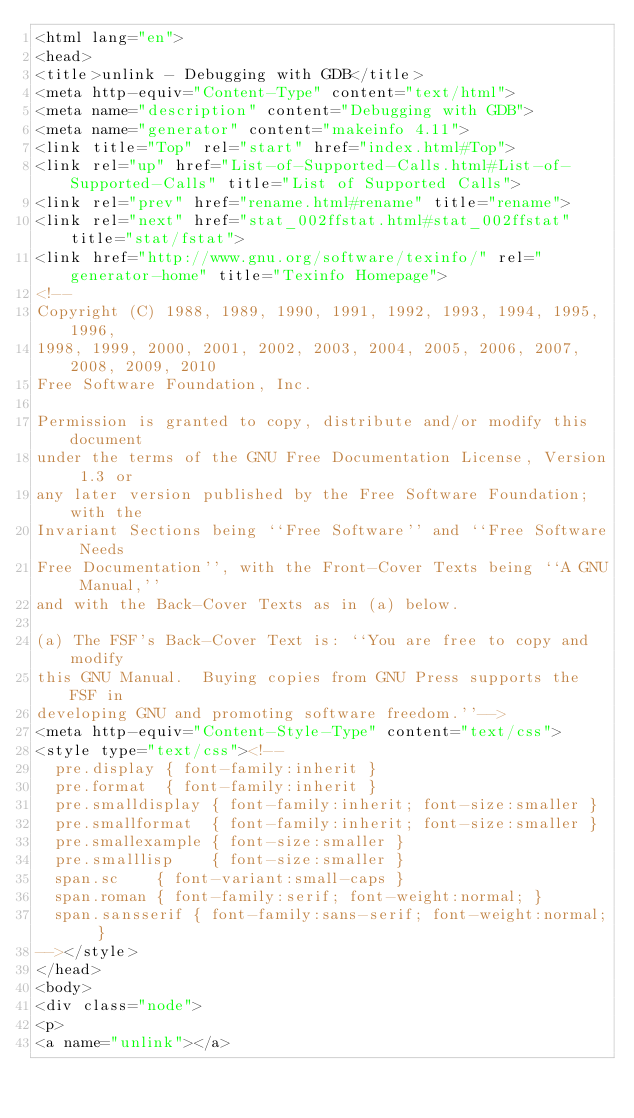<code> <loc_0><loc_0><loc_500><loc_500><_HTML_><html lang="en">
<head>
<title>unlink - Debugging with GDB</title>
<meta http-equiv="Content-Type" content="text/html">
<meta name="description" content="Debugging with GDB">
<meta name="generator" content="makeinfo 4.11">
<link title="Top" rel="start" href="index.html#Top">
<link rel="up" href="List-of-Supported-Calls.html#List-of-Supported-Calls" title="List of Supported Calls">
<link rel="prev" href="rename.html#rename" title="rename">
<link rel="next" href="stat_002ffstat.html#stat_002ffstat" title="stat/fstat">
<link href="http://www.gnu.org/software/texinfo/" rel="generator-home" title="Texinfo Homepage">
<!--
Copyright (C) 1988, 1989, 1990, 1991, 1992, 1993, 1994, 1995, 1996,
1998, 1999, 2000, 2001, 2002, 2003, 2004, 2005, 2006, 2007, 2008, 2009, 2010
Free Software Foundation, Inc.

Permission is granted to copy, distribute and/or modify this document
under the terms of the GNU Free Documentation License, Version 1.3 or
any later version published by the Free Software Foundation; with the
Invariant Sections being ``Free Software'' and ``Free Software Needs
Free Documentation'', with the Front-Cover Texts being ``A GNU Manual,''
and with the Back-Cover Texts as in (a) below.

(a) The FSF's Back-Cover Text is: ``You are free to copy and modify
this GNU Manual.  Buying copies from GNU Press supports the FSF in
developing GNU and promoting software freedom.''-->
<meta http-equiv="Content-Style-Type" content="text/css">
<style type="text/css"><!--
  pre.display { font-family:inherit }
  pre.format  { font-family:inherit }
  pre.smalldisplay { font-family:inherit; font-size:smaller }
  pre.smallformat  { font-family:inherit; font-size:smaller }
  pre.smallexample { font-size:smaller }
  pre.smalllisp    { font-size:smaller }
  span.sc    { font-variant:small-caps }
  span.roman { font-family:serif; font-weight:normal; } 
  span.sansserif { font-family:sans-serif; font-weight:normal; } 
--></style>
</head>
<body>
<div class="node">
<p>
<a name="unlink"></a></code> 